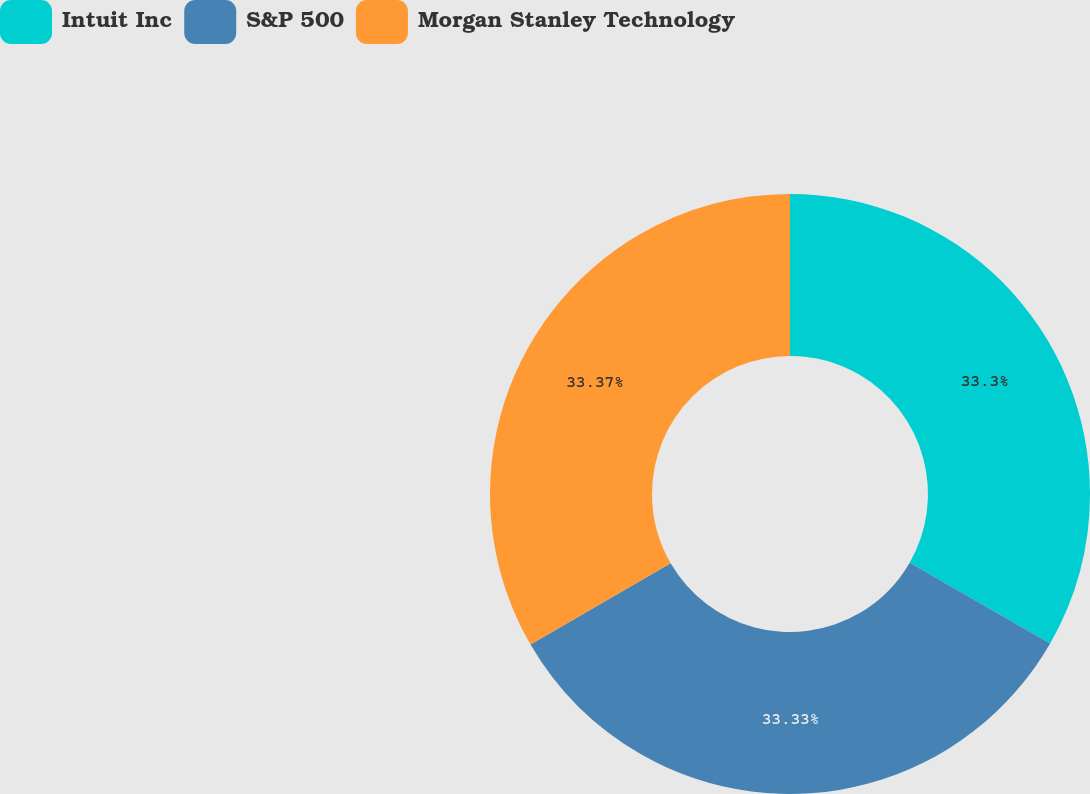<chart> <loc_0><loc_0><loc_500><loc_500><pie_chart><fcel>Intuit Inc<fcel>S&P 500<fcel>Morgan Stanley Technology<nl><fcel>33.3%<fcel>33.33%<fcel>33.37%<nl></chart> 